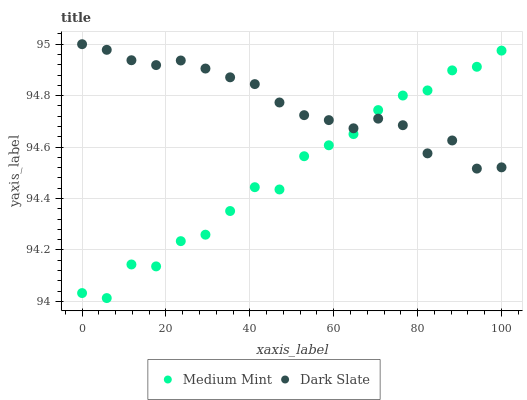Does Medium Mint have the minimum area under the curve?
Answer yes or no. Yes. Does Dark Slate have the maximum area under the curve?
Answer yes or no. Yes. Does Dark Slate have the minimum area under the curve?
Answer yes or no. No. Is Dark Slate the smoothest?
Answer yes or no. Yes. Is Medium Mint the roughest?
Answer yes or no. Yes. Is Dark Slate the roughest?
Answer yes or no. No. Does Medium Mint have the lowest value?
Answer yes or no. Yes. Does Dark Slate have the lowest value?
Answer yes or no. No. Does Dark Slate have the highest value?
Answer yes or no. Yes. Does Dark Slate intersect Medium Mint?
Answer yes or no. Yes. Is Dark Slate less than Medium Mint?
Answer yes or no. No. Is Dark Slate greater than Medium Mint?
Answer yes or no. No. 